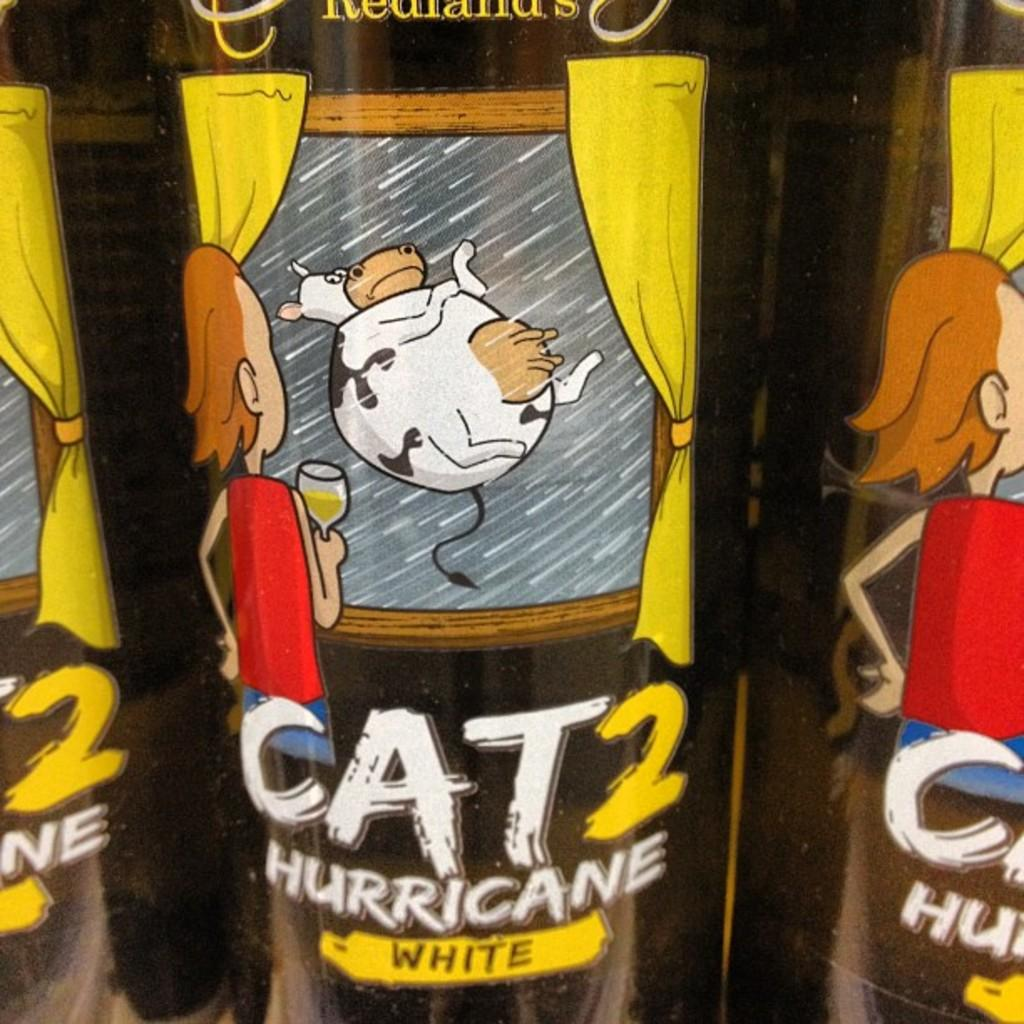What type of image is being described? The image is animated. What is the child in the image holding? The child is holding a glass in the image. What animated character is present in the image? A: There is an animated cow in the image. What type of window treatment is visible in the image? There are curtains in the image. Is there any text present in the image? Yes, there is text written on the image. What type of weather can be seen in the image? The image is animated and does not depict any weather conditions. Is there a house visible in the image? There is no house present in the image; it features a child holding a glass and an animated cow. 